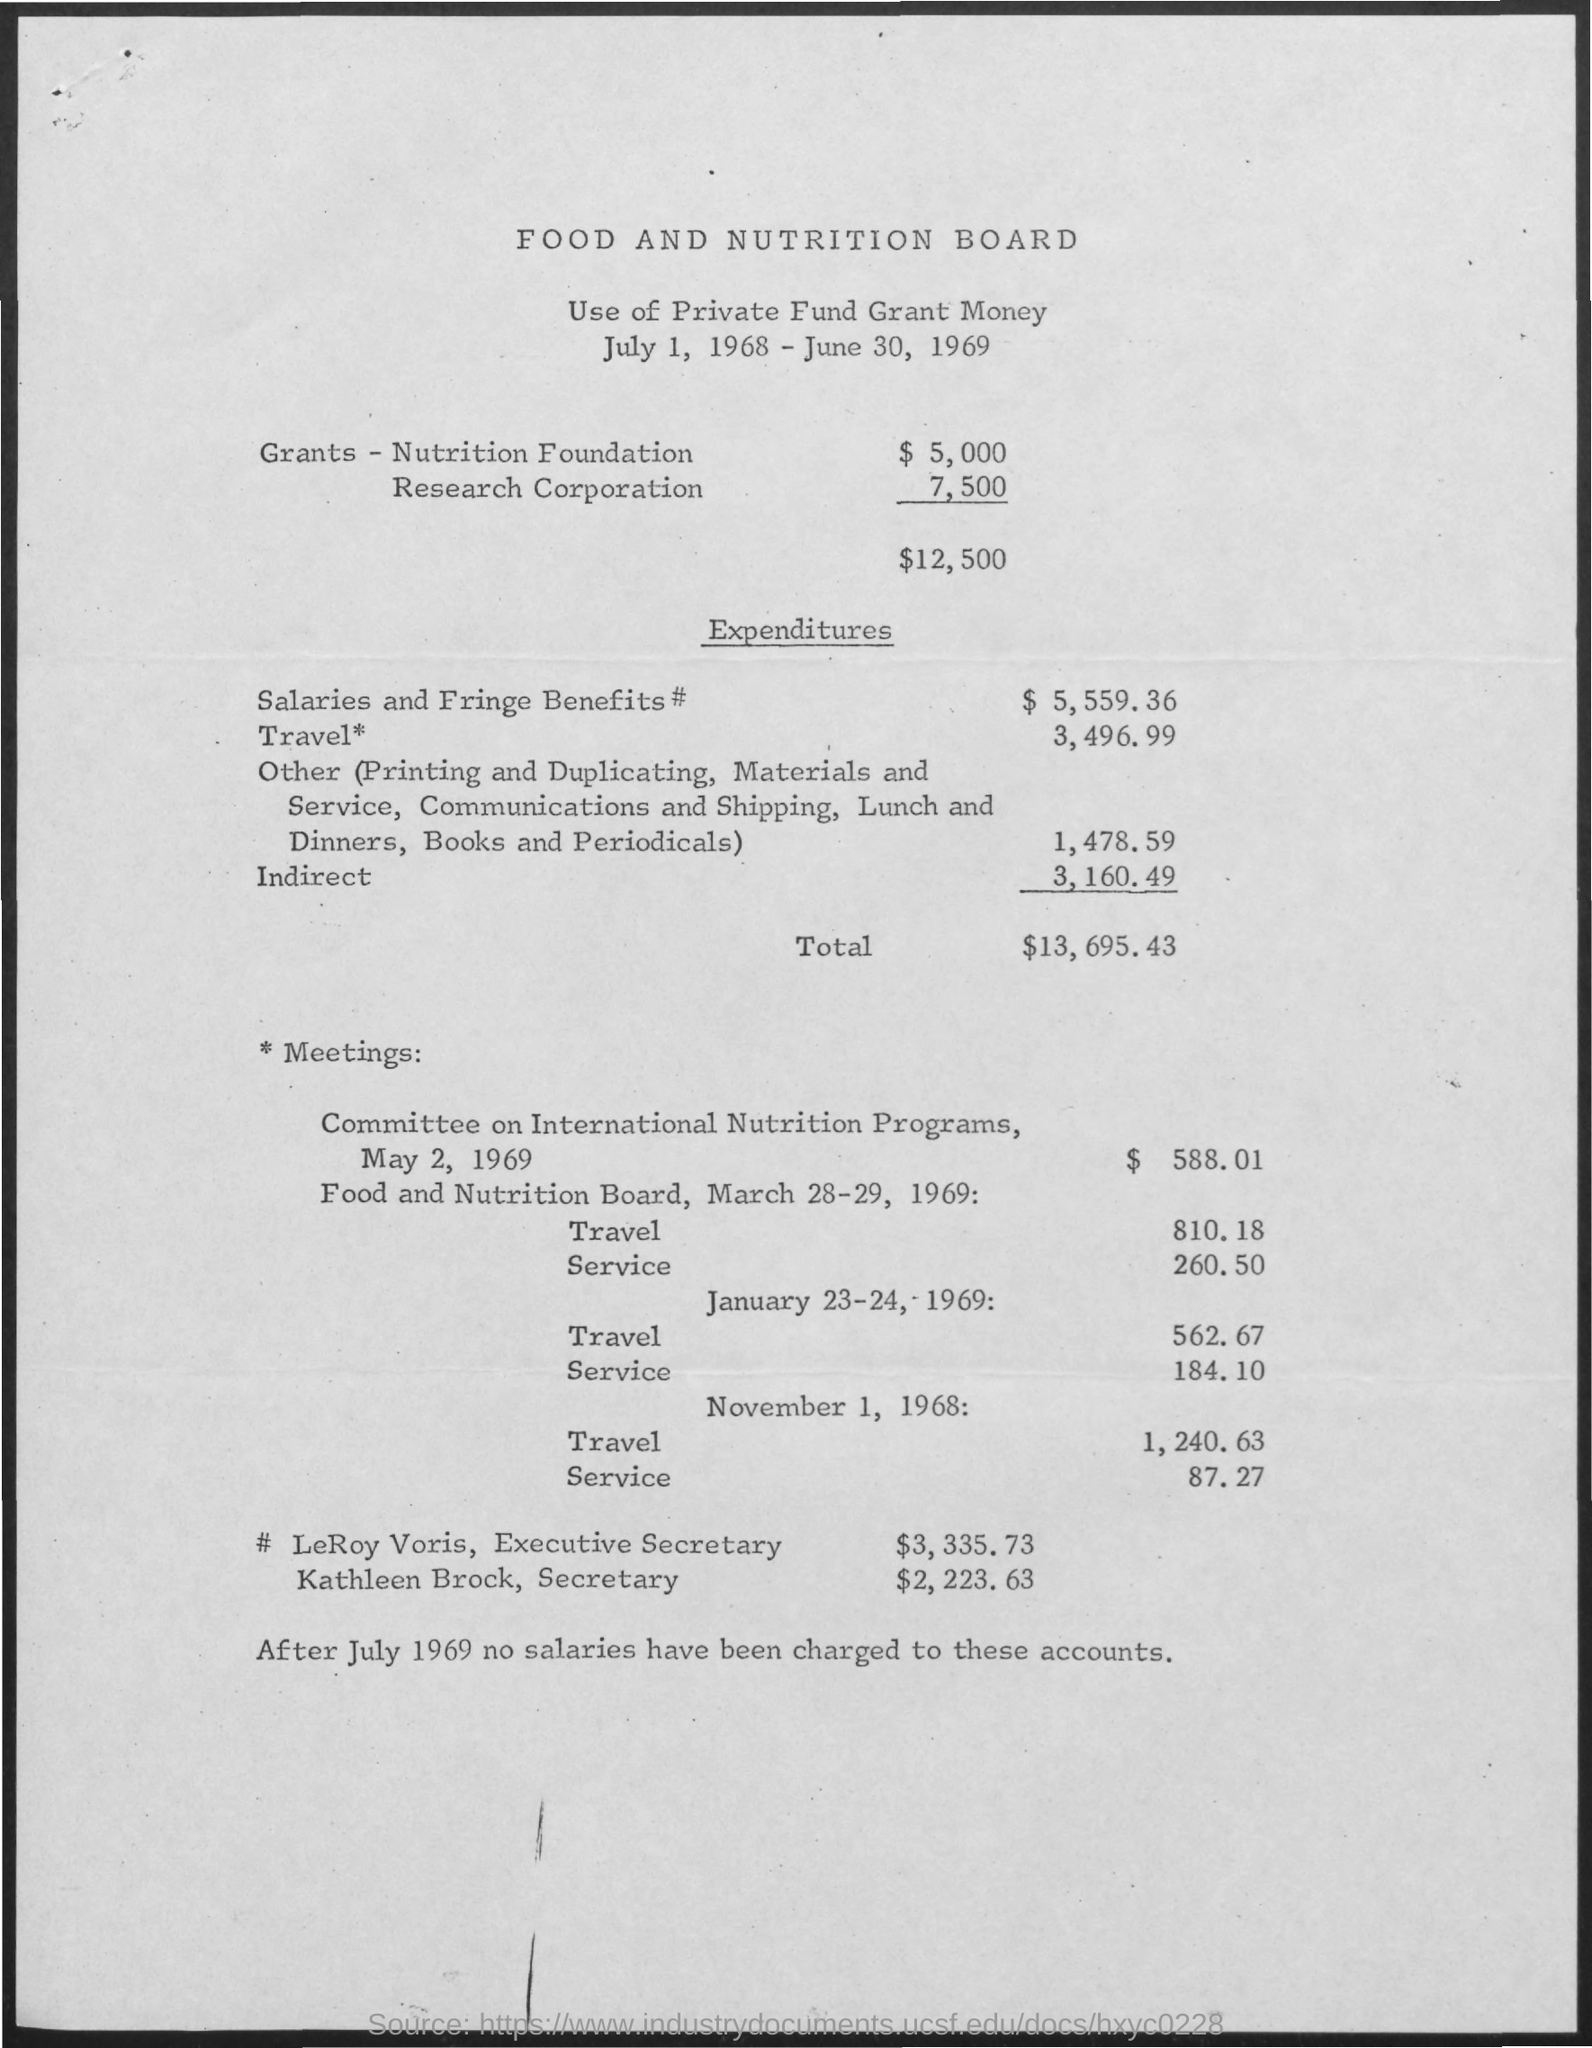Draw attention to some important aspects in this diagram. The expenditures for travel total $3,496.99. The total expenditures amount to $13,695.43. The total grants amount is $12,500. The expenditures for salaries and fringe benefits were $5,559.36. The indirect expenditures amounted to 3,160.49... 